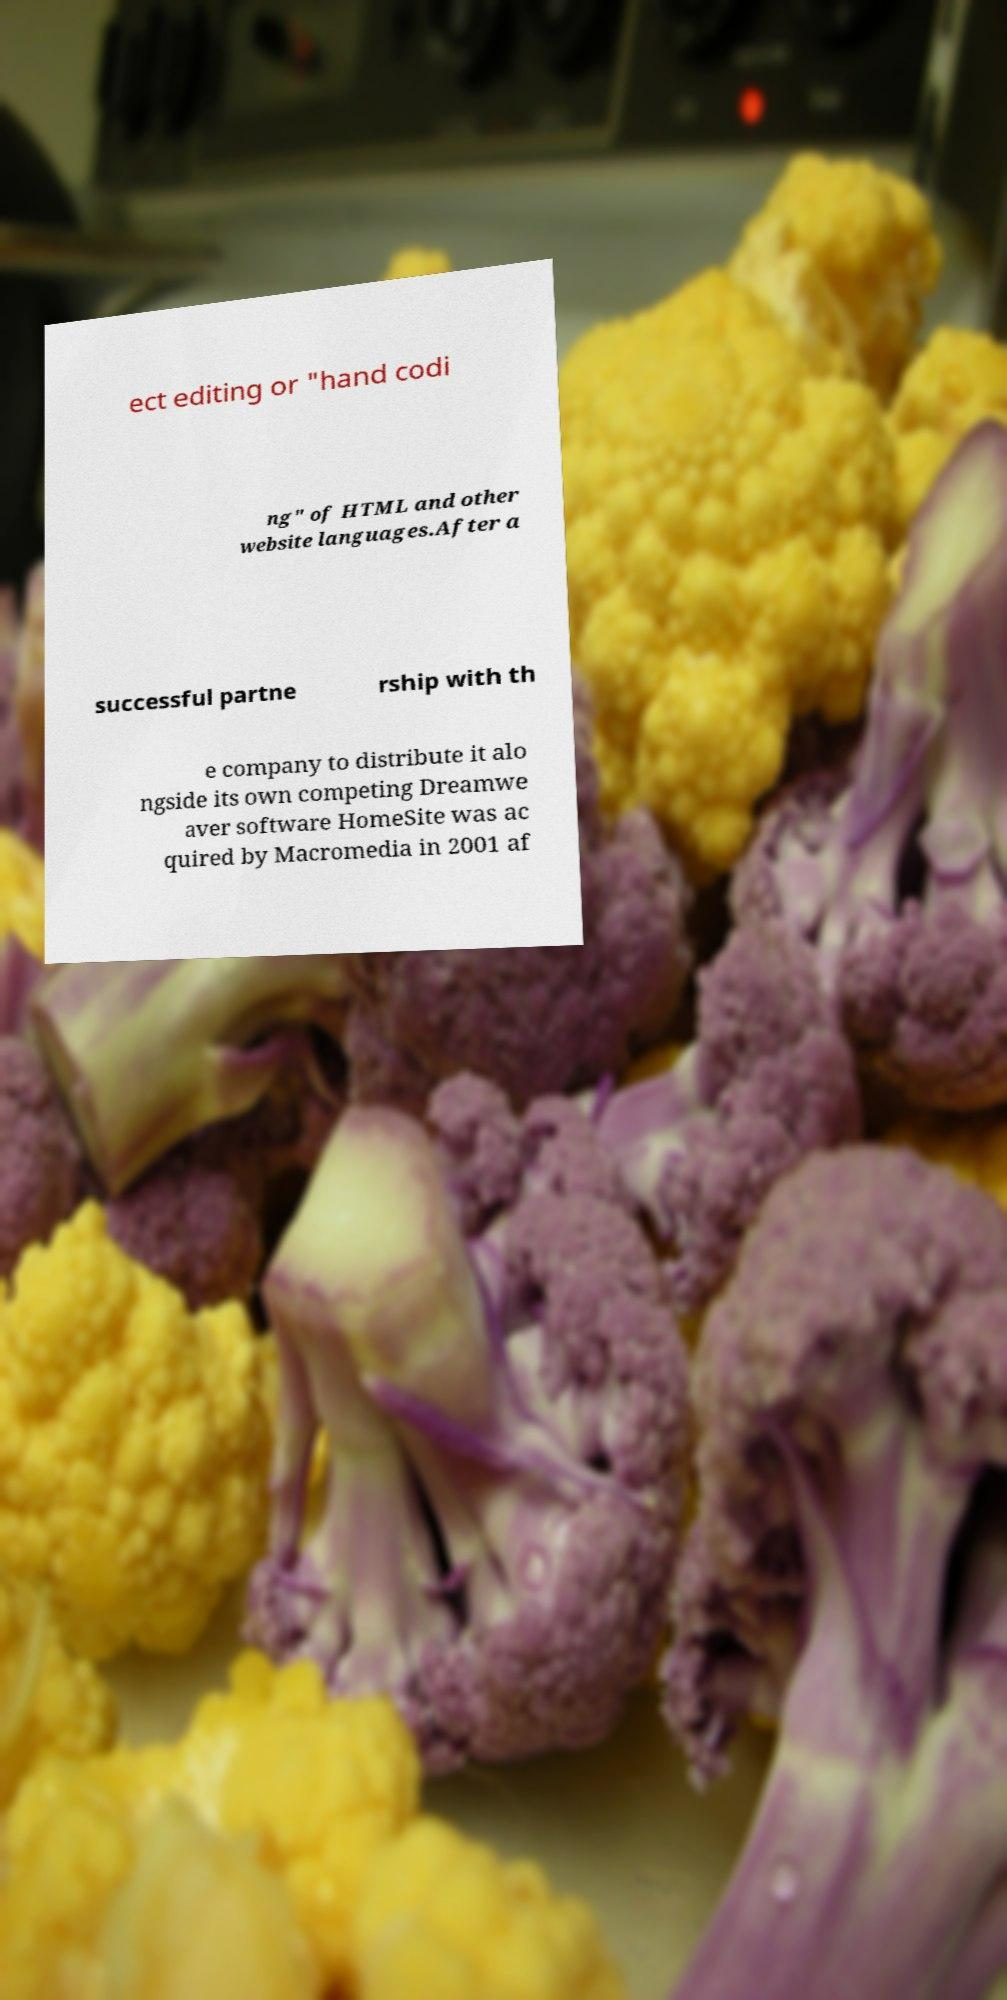Could you assist in decoding the text presented in this image and type it out clearly? ect editing or "hand codi ng" of HTML and other website languages.After a successful partne rship with th e company to distribute it alo ngside its own competing Dreamwe aver software HomeSite was ac quired by Macromedia in 2001 af 